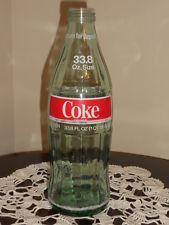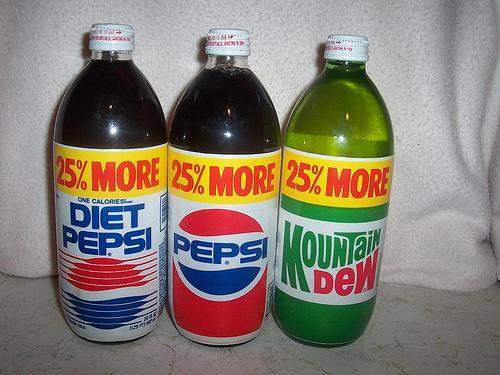The first image is the image on the left, the second image is the image on the right. For the images displayed, is the sentence "All of the bottles have caps." factually correct? Answer yes or no. No. The first image is the image on the left, the second image is the image on the right. Analyze the images presented: Is the assertion "The right image contains at least twice as many soda bottles as the left image." valid? Answer yes or no. Yes. 